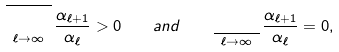Convert formula to latex. <formula><loc_0><loc_0><loc_500><loc_500>\varlimsup _ { \ell \to \infty } \frac { \alpha _ { \ell + 1 } } { \alpha _ { \ell } } > 0 \quad a n d \quad \varliminf _ { \ell \to \infty } \frac { \alpha _ { \ell + 1 } } { \alpha _ { \ell } } = 0 ,</formula> 